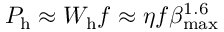<formula> <loc_0><loc_0><loc_500><loc_500>P _ { h } \approx { W } _ { h } f \approx \eta { f } \beta _ { \max } ^ { 1 . 6 }</formula> 